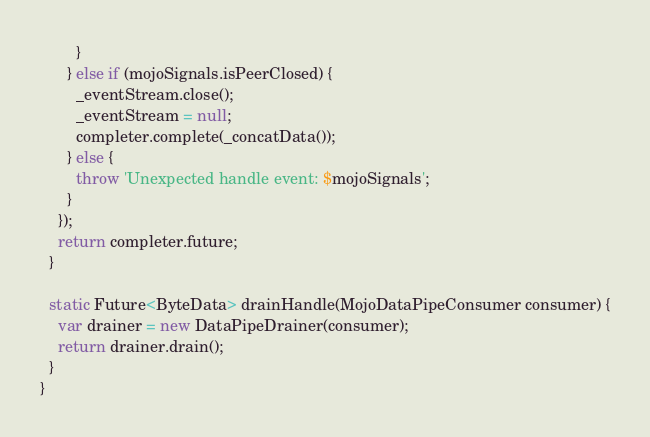<code> <loc_0><loc_0><loc_500><loc_500><_Dart_>        }
      } else if (mojoSignals.isPeerClosed) {
        _eventStream.close();
        _eventStream = null;
        completer.complete(_concatData());
      } else {
        throw 'Unexpected handle event: $mojoSignals';
      }
    });
    return completer.future;
  }

  static Future<ByteData> drainHandle(MojoDataPipeConsumer consumer) {
    var drainer = new DataPipeDrainer(consumer);
    return drainer.drain();
  }
}
</code> 